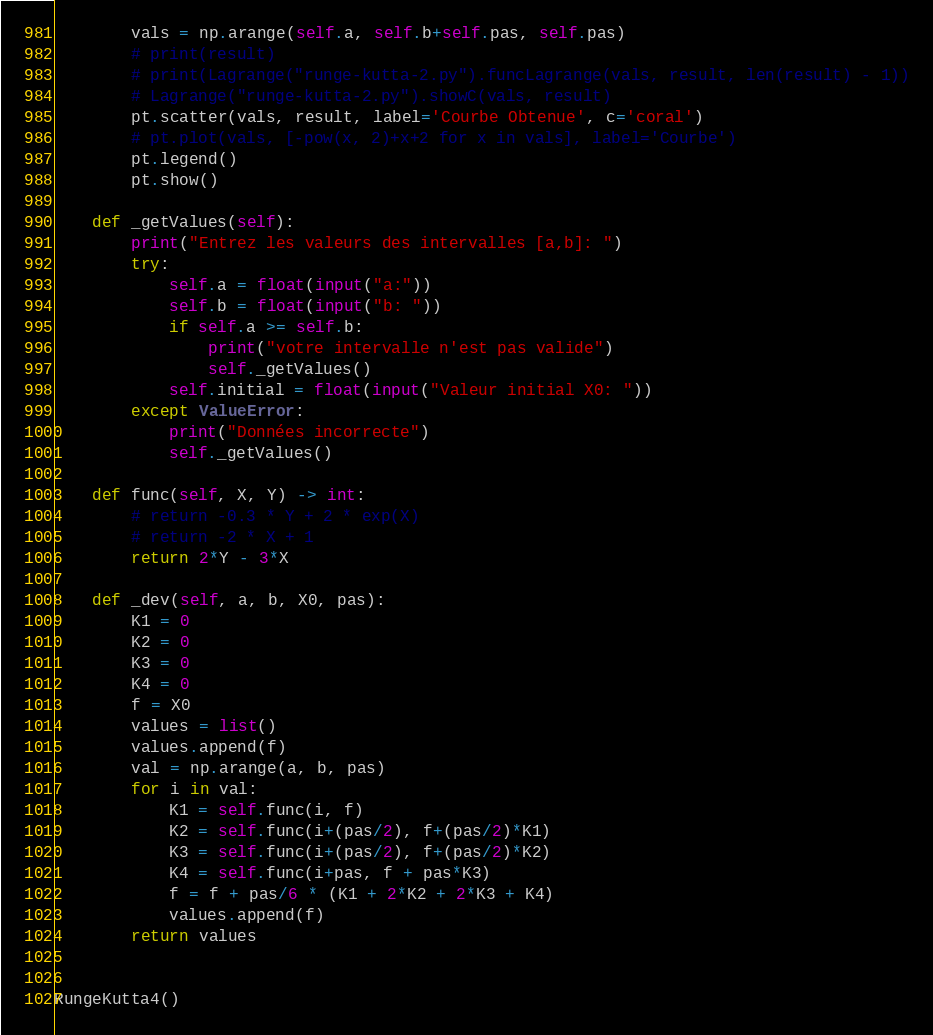Convert code to text. <code><loc_0><loc_0><loc_500><loc_500><_Python_>        vals = np.arange(self.a, self.b+self.pas, self.pas)
        # print(result)
        # print(Lagrange("runge-kutta-2.py").funcLagrange(vals, result, len(result) - 1))
        # Lagrange("runge-kutta-2.py").showC(vals, result)
        pt.scatter(vals, result, label='Courbe Obtenue', c='coral')
        # pt.plot(vals, [-pow(x, 2)+x+2 for x in vals], label='Courbe')
        pt.legend()
        pt.show()

    def _getValues(self):
        print("Entrez les valeurs des intervalles [a,b]: ")
        try:
            self.a = float(input("a:"))
            self.b = float(input("b: "))
            if self.a >= self.b:
                print("votre intervalle n'est pas valide")
                self._getValues()
            self.initial = float(input("Valeur initial X0: "))
        except ValueError:
            print("Données incorrecte")
            self._getValues()

    def func(self, X, Y) -> int:
        # return -0.3 * Y + 2 * exp(X)
        # return -2 * X + 1
        return 2*Y - 3*X

    def _dev(self, a, b, X0, pas):
        K1 = 0
        K2 = 0
        K3 = 0
        K4 = 0
        f = X0
        values = list()
        values.append(f)
        val = np.arange(a, b, pas)
        for i in val:
            K1 = self.func(i, f)
            K2 = self.func(i+(pas/2), f+(pas/2)*K1)
            K3 = self.func(i+(pas/2), f+(pas/2)*K2)
            K4 = self.func(i+pas, f + pas*K3)
            f = f + pas/6 * (K1 + 2*K2 + 2*K3 + K4)
            values.append(f)
        return values


RungeKutta4()
</code> 